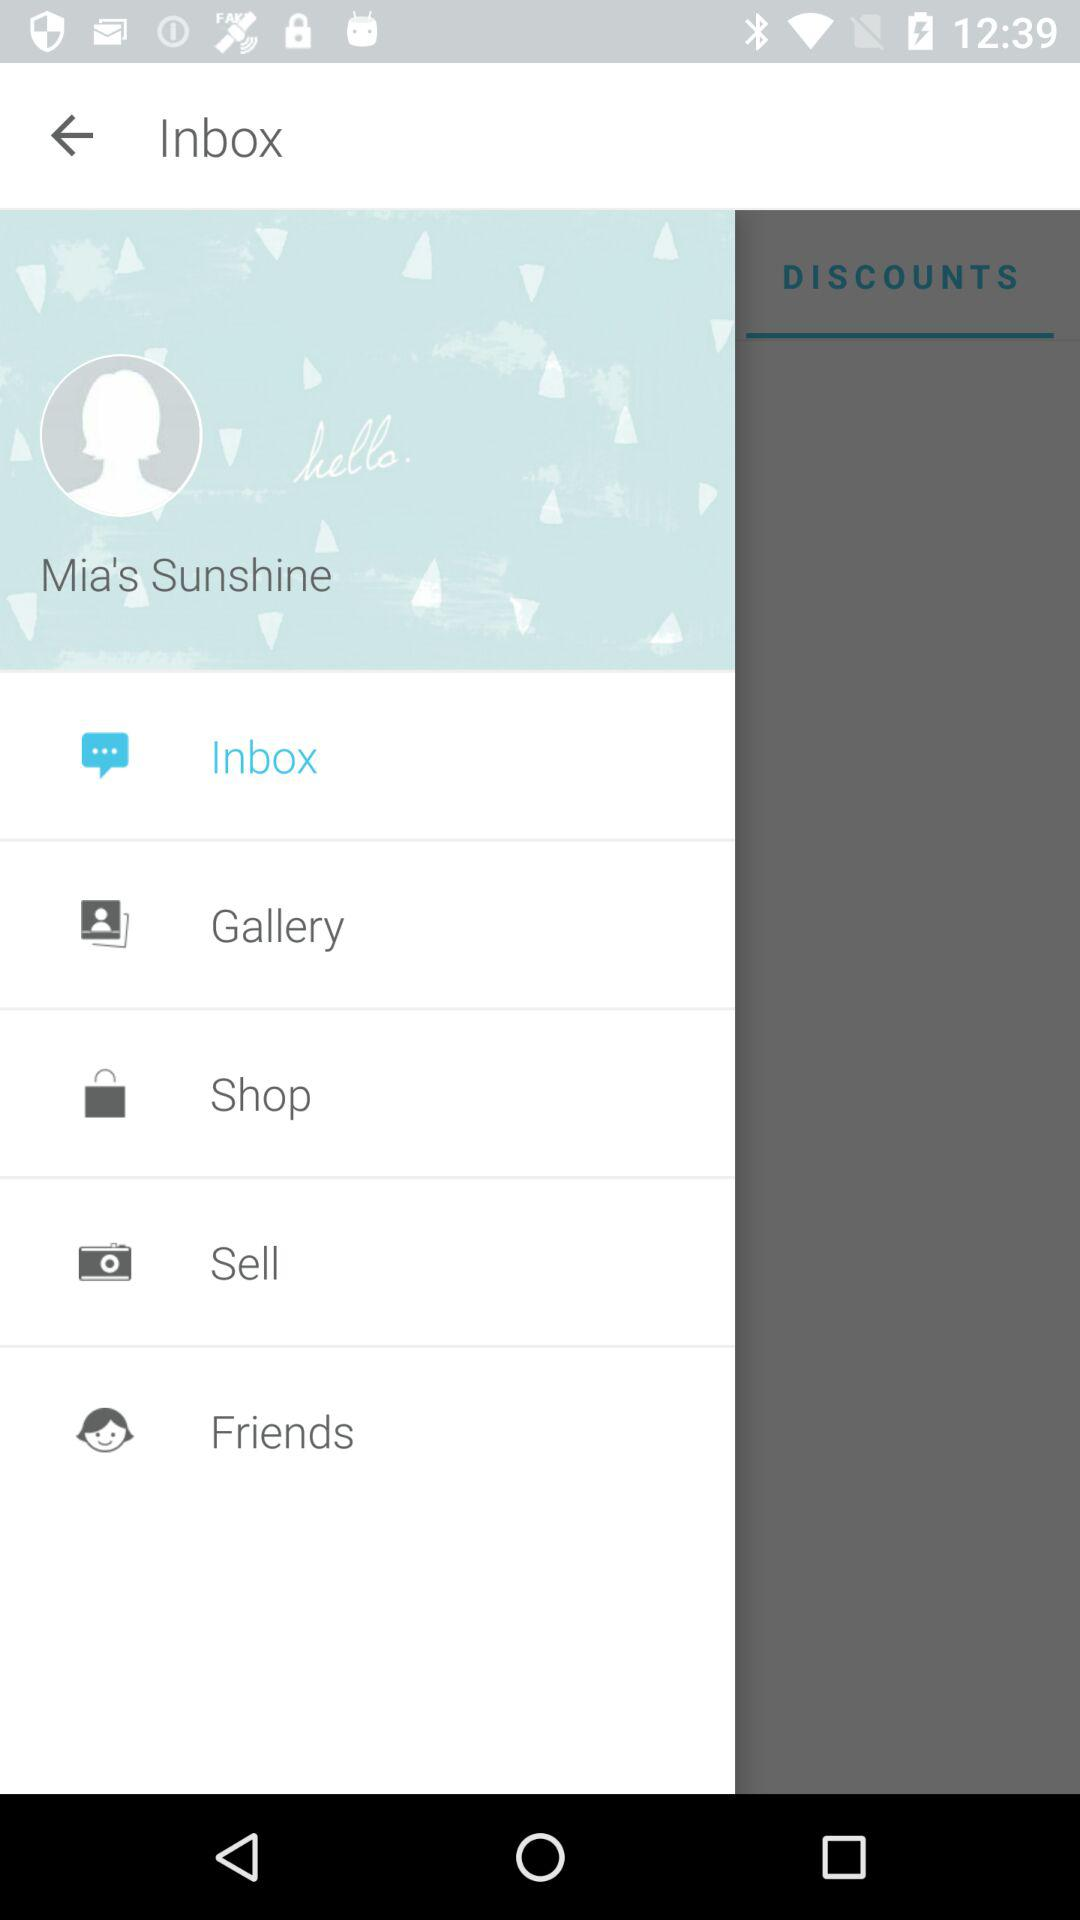What is the username? The username is "Mia's Sunshine". 